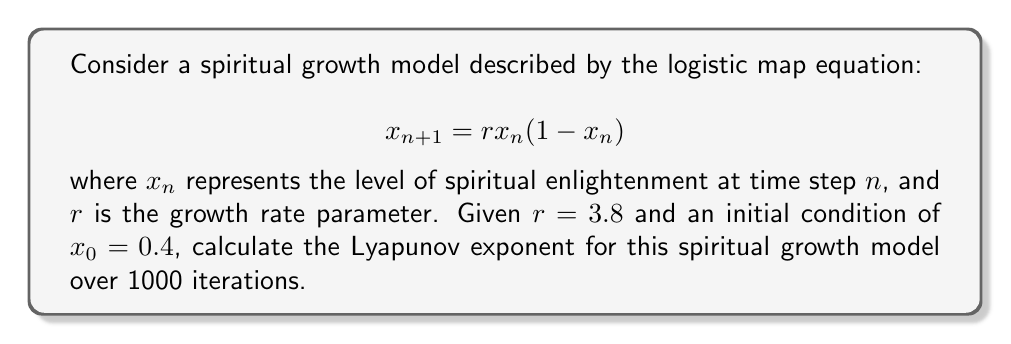Can you answer this question? To calculate the Lyapunov exponent for this spiritual growth model, we'll follow these steps:

1. The Lyapunov exponent $\lambda$ for the logistic map is given by:

   $$\lambda = \lim_{N \to \infty} \frac{1}{N} \sum_{n=0}^{N-1} \ln|f'(x_n)|$$

   where $f'(x)$ is the derivative of the logistic map function.

2. For the logistic map, $f'(x) = r(1-2x)$

3. We'll use the given parameters: $r = 3.8$, $x_0 = 0.4$, and $N = 1000$

4. Implement the following algorithm:
   - Initialize $\text{sum} = 0$
   - For $n = 0$ to $999$:
     - Calculate $x_{n+1} = rx_n(1-x_n)$
     - Calculate $|f'(x_n)| = |3.8(1-2x_n)|$
     - Add $\ln|f'(x_n)|$ to $\text{sum}$
     - Update $x_n$ to $x_{n+1}$

5. After the loop, calculate $\lambda = \frac{\text{sum}}{1000}$

Using a computer program or calculator to perform these iterations, we find:

$$\lambda \approx 0.5924$$

This positive Lyapunov exponent indicates chaotic behavior in the spiritual growth model, suggesting that small differences in initial spiritual states can lead to vastly different outcomes over time.
Answer: $\lambda \approx 0.5924$ 